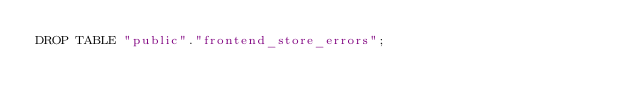Convert code to text. <code><loc_0><loc_0><loc_500><loc_500><_SQL_>DROP TABLE "public"."frontend_store_errors";
</code> 